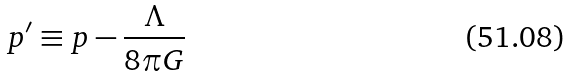<formula> <loc_0><loc_0><loc_500><loc_500>p ^ { \prime } \equiv p - \frac { \Lambda } { 8 \pi G }</formula> 